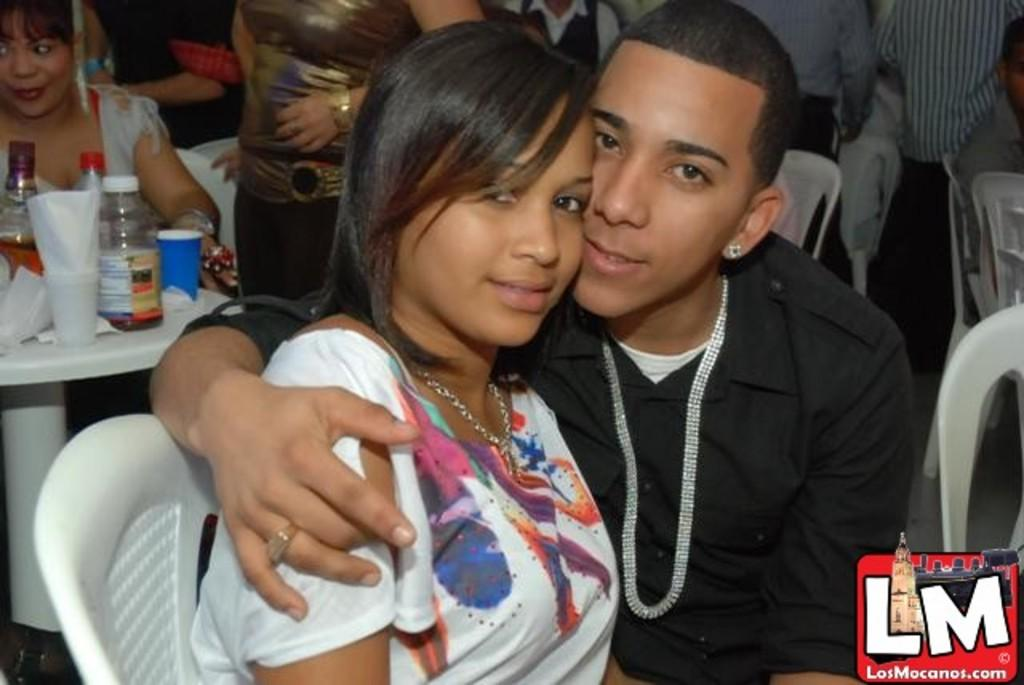What is the girl doing in the image? The girl is sitting on a chair in the image. What is the man doing in relation to the girl? The man is holding the girl in the image. What can be seen in the background of the image? There is a table in the background of the image. Are there any other people present in the image? Yes, there are other people standing in the image. What type of day is depicted in the image? The provided facts do not mention any specific day or weather conditions, so it cannot be determined from the image. Can you see a lake in the image? There is no lake present in the image. 